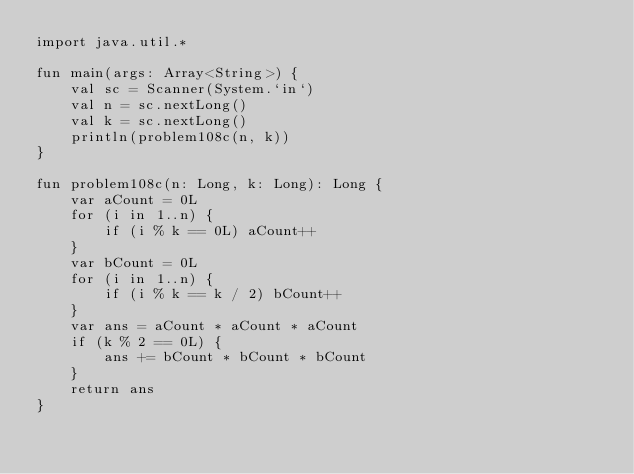Convert code to text. <code><loc_0><loc_0><loc_500><loc_500><_Kotlin_>import java.util.*

fun main(args: Array<String>) {
    val sc = Scanner(System.`in`)
    val n = sc.nextLong()
    val k = sc.nextLong()
    println(problem108c(n, k))
}

fun problem108c(n: Long, k: Long): Long {
    var aCount = 0L
    for (i in 1..n) {
        if (i % k == 0L) aCount++
    }
    var bCount = 0L
    for (i in 1..n) {
        if (i % k == k / 2) bCount++
    }
    var ans = aCount * aCount * aCount
    if (k % 2 == 0L) {
        ans += bCount * bCount * bCount
    }
    return ans
}</code> 